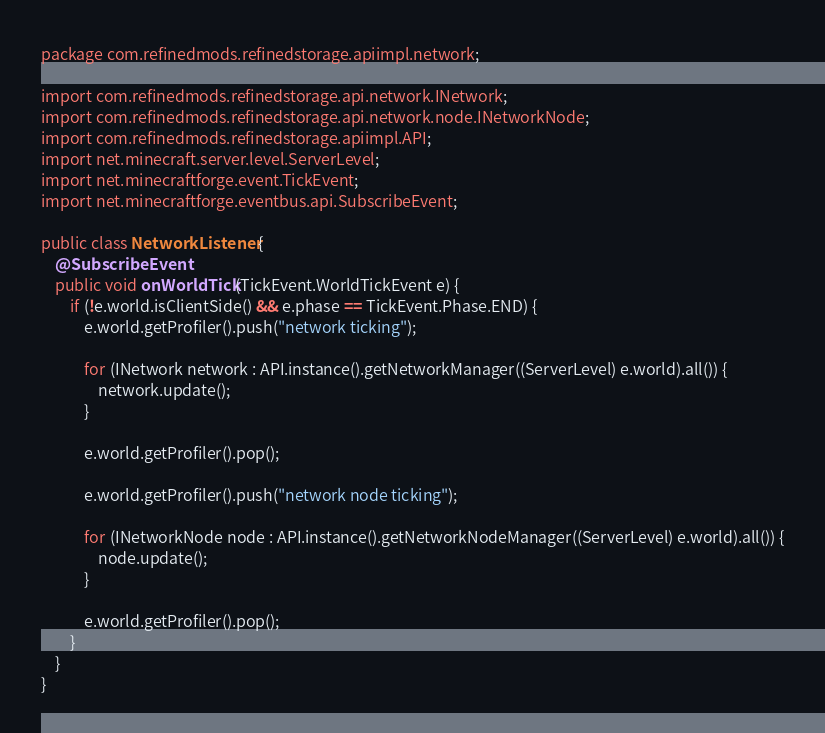Convert code to text. <code><loc_0><loc_0><loc_500><loc_500><_Java_>package com.refinedmods.refinedstorage.apiimpl.network;

import com.refinedmods.refinedstorage.api.network.INetwork;
import com.refinedmods.refinedstorage.api.network.node.INetworkNode;
import com.refinedmods.refinedstorage.apiimpl.API;
import net.minecraft.server.level.ServerLevel;
import net.minecraftforge.event.TickEvent;
import net.minecraftforge.eventbus.api.SubscribeEvent;

public class NetworkListener {
    @SubscribeEvent
    public void onWorldTick(TickEvent.WorldTickEvent e) {
        if (!e.world.isClientSide() && e.phase == TickEvent.Phase.END) {
            e.world.getProfiler().push("network ticking");

            for (INetwork network : API.instance().getNetworkManager((ServerLevel) e.world).all()) {
                network.update();
            }

            e.world.getProfiler().pop();

            e.world.getProfiler().push("network node ticking");

            for (INetworkNode node : API.instance().getNetworkNodeManager((ServerLevel) e.world).all()) {
                node.update();
            }

            e.world.getProfiler().pop();
        }
    }
}
</code> 